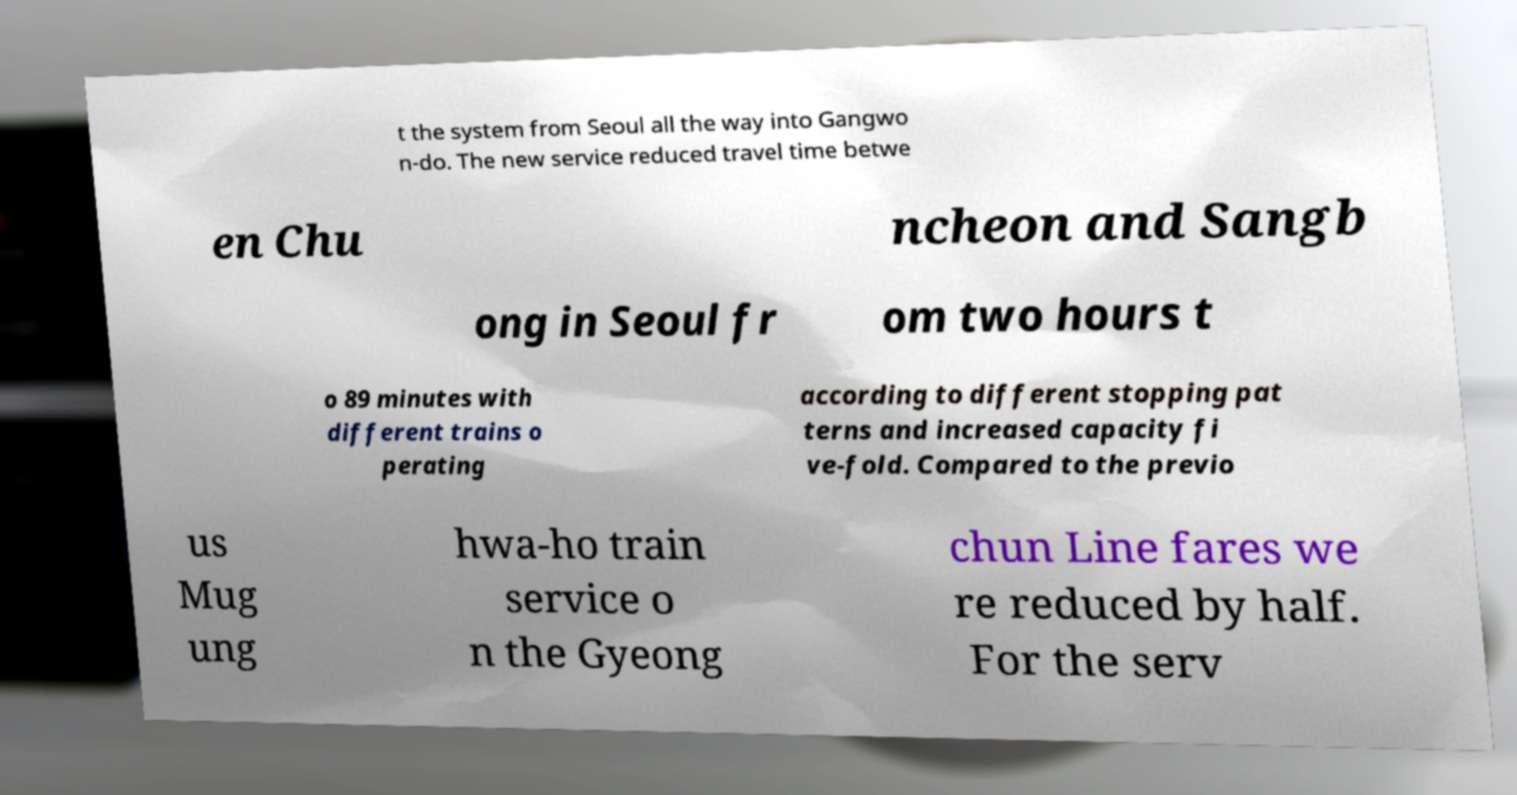Could you extract and type out the text from this image? t the system from Seoul all the way into Gangwo n-do. The new service reduced travel time betwe en Chu ncheon and Sangb ong in Seoul fr om two hours t o 89 minutes with different trains o perating according to different stopping pat terns and increased capacity fi ve-fold. Compared to the previo us Mug ung hwa-ho train service o n the Gyeong chun Line fares we re reduced by half. For the serv 